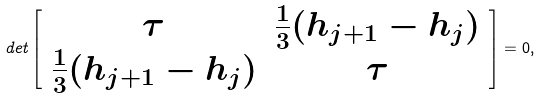<formula> <loc_0><loc_0><loc_500><loc_500>d e t \left [ \begin{array} { c c } \tau & \frac { 1 } { 3 } ( h _ { j + 1 } - h _ { j } ) \\ \frac { 1 } { 3 } ( h _ { j + 1 } - h _ { j } ) & \tau \end{array} \right ] = 0 ,</formula> 